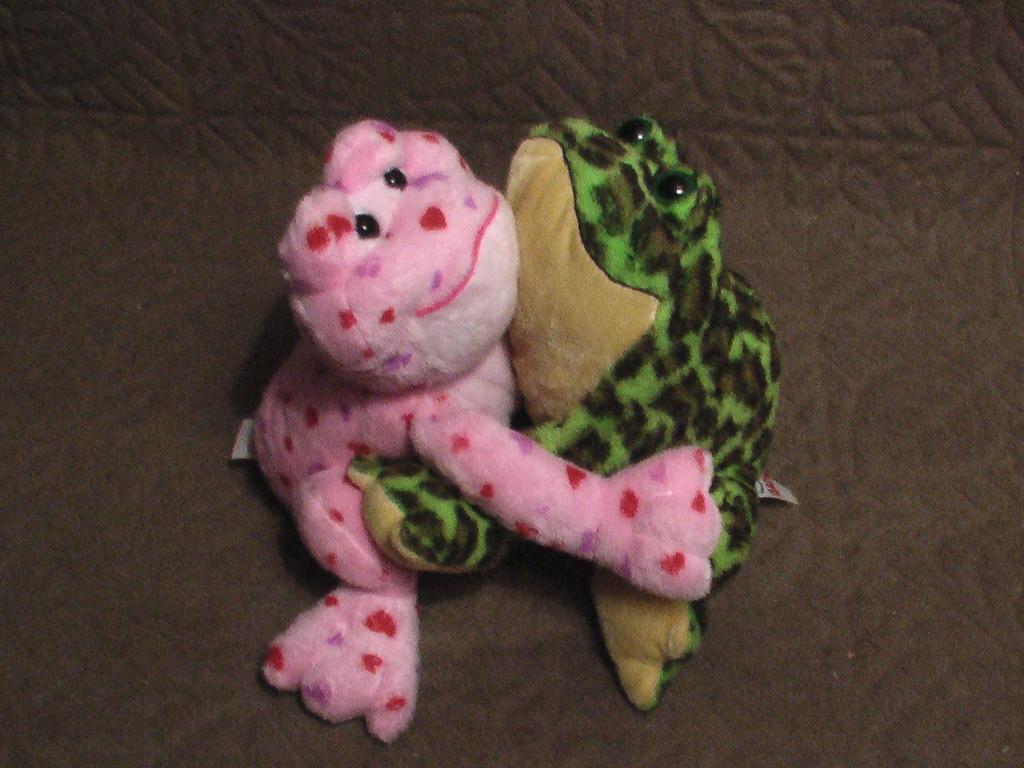Can you describe this image briefly? In the image I can see two dolls which are in the shape of frogs. 